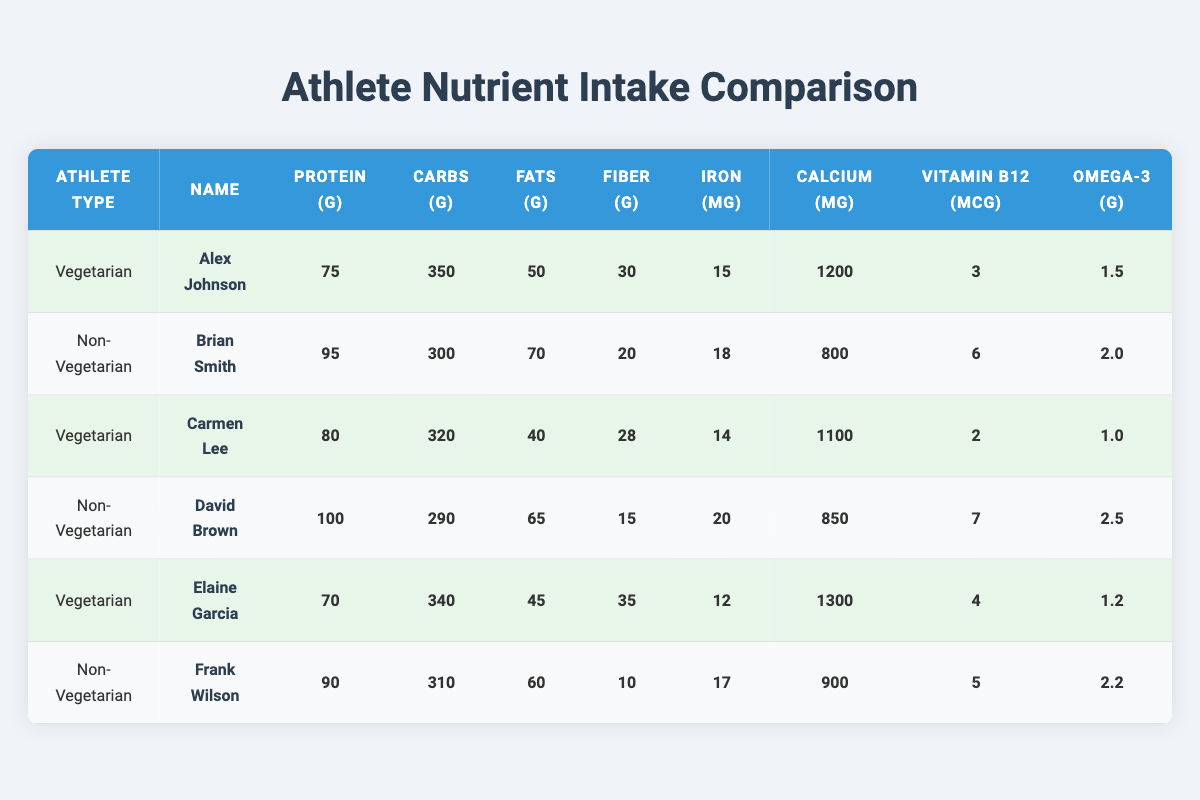What's the protein intake of vegetarian athlete Alex Johnson? The table lists Alex Johnson under the vegetarian category and shows his protein intake as 75 grams.
Answer: 75 grams Who has higher calcium intake, vegetarian Elaine Garcia or non-vegetarian Brian Smith? Elaine Garcia has a calcium intake of 1300 mg while Brian Smith has 800 mg. Since 1300 mg is greater than 800 mg, Elaine Garcia has a higher calcium intake.
Answer: Elaine Garcia What is the total protein intake of all non-vegetarian athletes? There are three non-vegetarian athletes with the following protein intakes: 95 g, 100 g, and 90 g. Adding these together: 95 + 100 + 90 = 285 g.
Answer: 285 grams Is the fiber intake of vegetarian athlete Carmen Lee higher than that of non-vegetarian athlete Frank Wilson? Carmen Lee has a fiber intake of 28 grams, while Frank Wilson has a fiber intake of 10 grams. Since 28 is greater than 10, Carmen Lee has a higher fiber intake.
Answer: Yes What is the average omega-3 intake for all vegetarian athletes? The omega-3 values for vegetarian athletes are 1.5 g, 1.0 g, and 1.2 g. To find the average, sum these values: 1.5 + 1.0 + 1.2 = 3.7 g. Then divide by 3: 3.7 / 3 = approximately 1.23 g.
Answer: 1.23 grams Which athlete has the highest iron intake? In the table, David Brown (non-vegetarian) has an iron intake of 20 mg, while the highest intake of vegetarian athletes is 15 mg (Alex Johnson). Therefore, David Brown has the highest iron intake.
Answer: David Brown How many more grams of fat does non-vegetarian Brian Smith consume compared to vegetarian Alex Johnson? Brian Smith's fat intake is 70 g and Alex Johnson's fat intake is 50 g. The difference is 70 - 50 = 20 g, indicating Brian Smith consumes 20 grams more fat.
Answer: 20 grams Has any vegetarian athlete consumed more carbohydrates than non-vegetarian David Brown? David Brown's carbohydrates intake is 290 g. The carbohydrate intakes for the vegetarian athletes are 350 g (Alex Johnson), 320 g (Carmen Lee), and 340 g (Elaine Garcia). Since 350, 320, and 340 are all higher than 290, yes, at least one vegetarian athlete has consumed more carbohydrates.
Answer: Yes What is the combined fiber intake of all vegetarian athletes? The fiber intakes for vegetarian athletes are 30 g (Alex Johnson), 28 g (Carmen Lee), and 35 g (Elaine Garcia). Adding these yields: 30 + 28 + 35 = 93 g.
Answer: 93 grams 